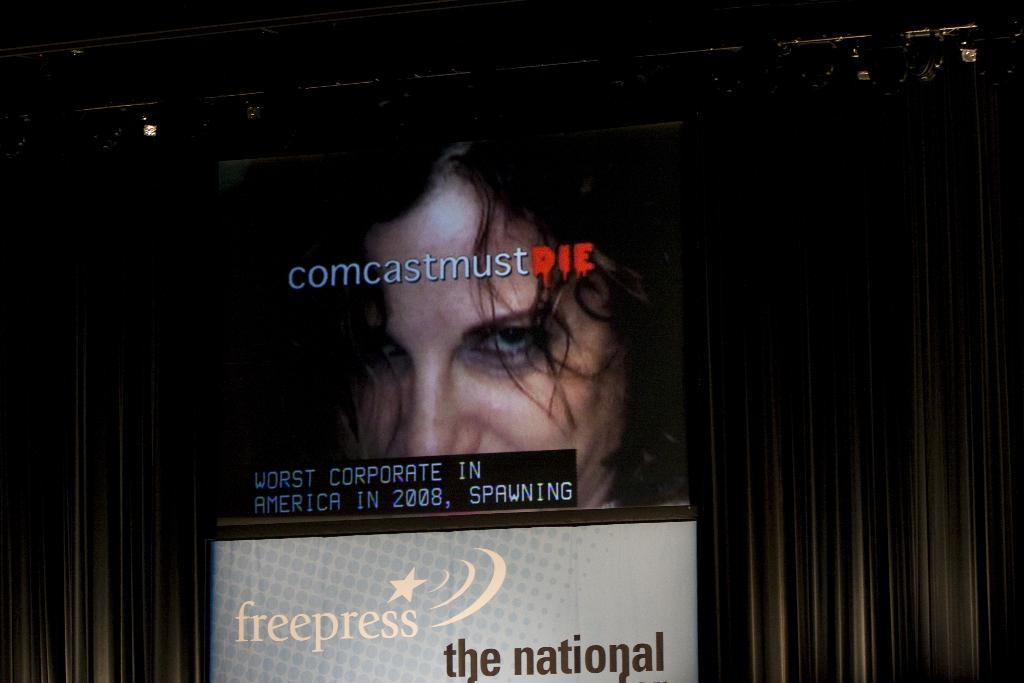What is depicted on the boards in the image? The boards have text and images in the image. What can be seen behind the boards in the image? There is a background visible in the image. What is located at the top of the image? There are objects at the top of the image. What is the average income of the people in the country depicted in the image? There is no country depicted in the image, so it is not possible to determine the average income of the people. 